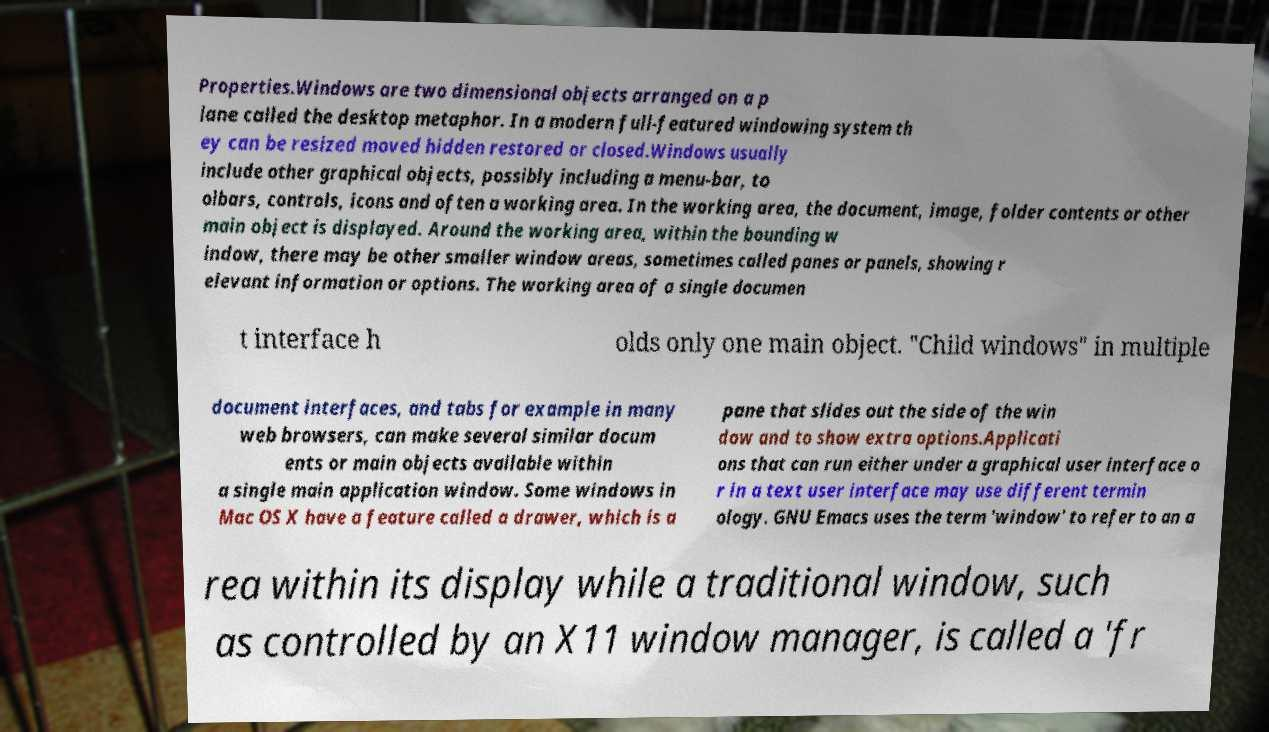Can you accurately transcribe the text from the provided image for me? Properties.Windows are two dimensional objects arranged on a p lane called the desktop metaphor. In a modern full-featured windowing system th ey can be resized moved hidden restored or closed.Windows usually include other graphical objects, possibly including a menu-bar, to olbars, controls, icons and often a working area. In the working area, the document, image, folder contents or other main object is displayed. Around the working area, within the bounding w indow, there may be other smaller window areas, sometimes called panes or panels, showing r elevant information or options. The working area of a single documen t interface h olds only one main object. "Child windows" in multiple document interfaces, and tabs for example in many web browsers, can make several similar docum ents or main objects available within a single main application window. Some windows in Mac OS X have a feature called a drawer, which is a pane that slides out the side of the win dow and to show extra options.Applicati ons that can run either under a graphical user interface o r in a text user interface may use different termin ology. GNU Emacs uses the term 'window' to refer to an a rea within its display while a traditional window, such as controlled by an X11 window manager, is called a 'fr 